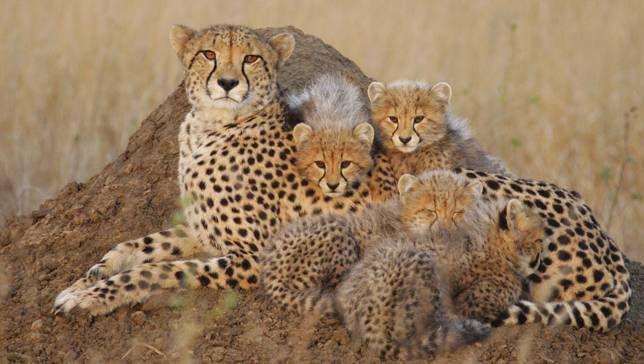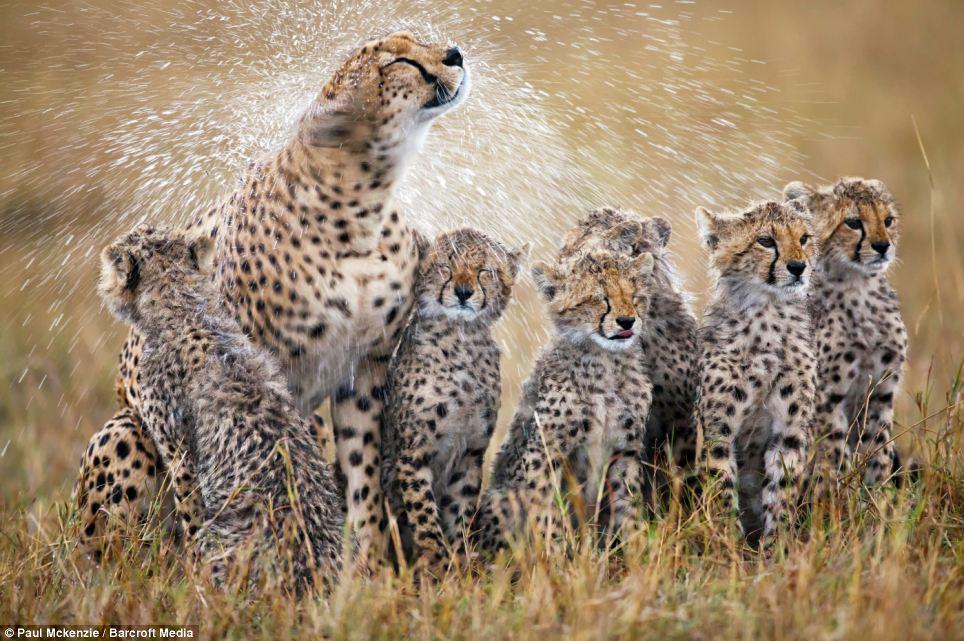The first image is the image on the left, the second image is the image on the right. Analyze the images presented: Is the assertion "Each image shows a close group of wild cats, and no image shows a prey animal." valid? Answer yes or no. Yes. The first image is the image on the left, the second image is the image on the right. For the images displayed, is the sentence "The cheetahs are shown with their prey in at least one of the images." factually correct? Answer yes or no. No. 